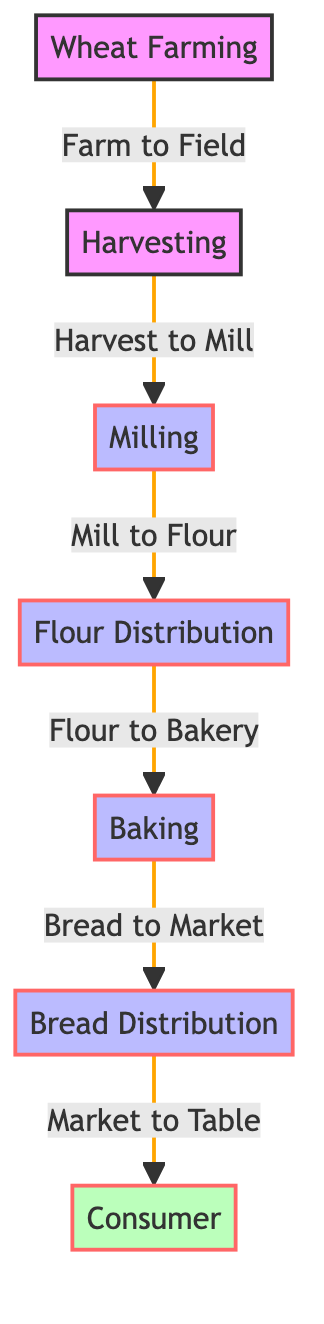What is the starting point of the food chain? The diagram indicates that the starting point of the food chain is "Wheat Farming". This is the first node listed in the diagram, serving as the initial part of the entire process.
Answer: Wheat Farming How many processes are shown in the diagram? The diagram displays three processes which include "Milling", "Flour Distribution", and "Baking". Counting the process nodes provides the answer.
Answer: 3 What connects harvesting to milling? The link between harvesting (node 2) and milling (node 3) is labeled "Harvest to Mill". This indicates the transfer directly from one stage to the next within the process of creating bread.
Answer: Harvest to Mill Which node represents the end consumer? The diagram clearly shows "Consumer" as the final node in the flow, thus representing the end consumer in the process of bread production. This node is the last one in the chain.
Answer: Consumer What is the last process before the bread reaches the consumer? The last process before reaching the consumer is "Bread Distribution". According to the flow, it follows "Baking" and leads directly to the "Consumer" node.
Answer: Bread Distribution How many total connections are in the diagram? By counting the connections between the nodes, we see there are six arrows connecting each step in the food chain from "Wheat Farming" to "Consumer".
Answer: 6 What is the direct relationship between milling and flour distribution? Milling directly leads to flour distribution, as indicated by the arrow between the nodes labeled "Mill to Flour". This shows the progression from milling wheat to distributing flour.
Answer: Mill to Flour What process comes after baking in the diagram? The process that comes immediately after baking is "Bread Distribution", as indicated by the direct arrow leading from the "Baking" node to the "Bread Distribution" node.
Answer: Bread Distribution What is the purpose of the flow from field to table? The purpose is to illustrate the stages of how wheat, starting from farming in the field, ultimately reaches the table in the form of bread for consumption. This encompasses all nodes and processes depicted in the diagram.
Answer: Illustrate stages from field to table 